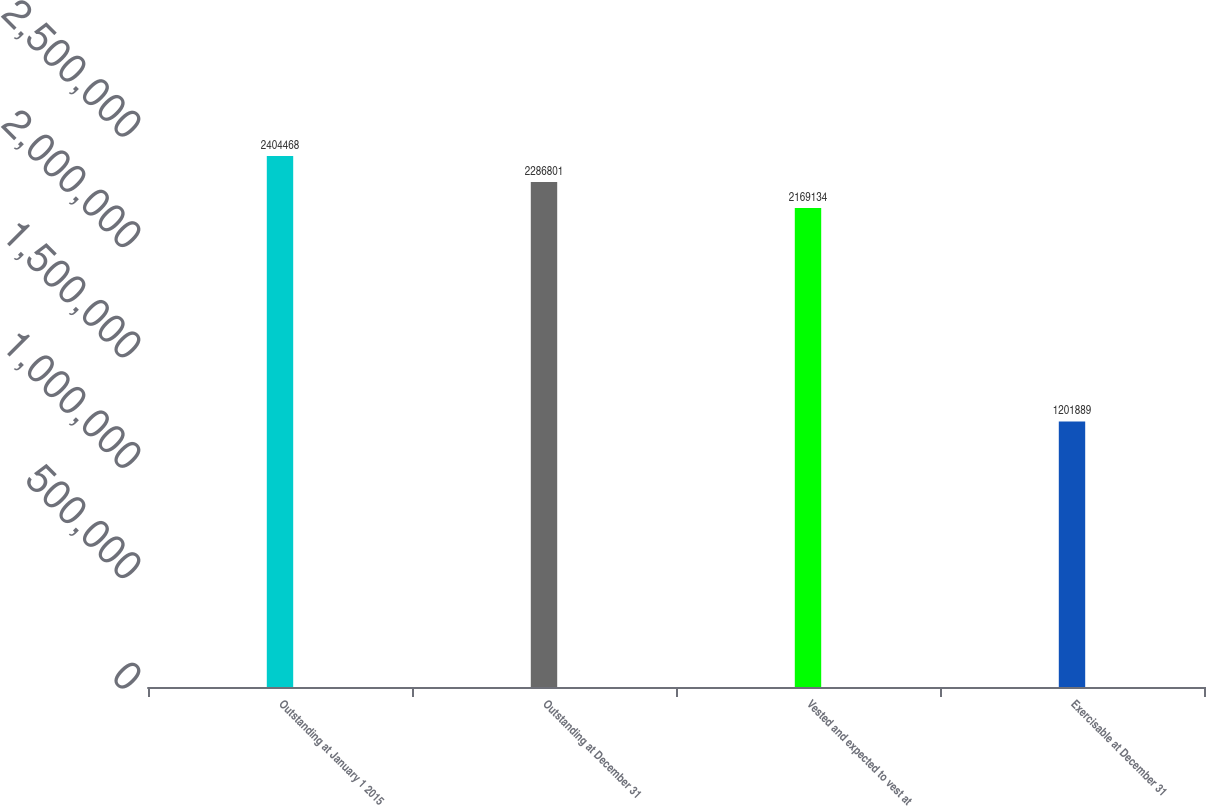Convert chart. <chart><loc_0><loc_0><loc_500><loc_500><bar_chart><fcel>Outstanding at January 1 2015<fcel>Outstanding at December 31<fcel>Vested and expected to vest at<fcel>Exercisable at December 31<nl><fcel>2.40447e+06<fcel>2.2868e+06<fcel>2.16913e+06<fcel>1.20189e+06<nl></chart> 